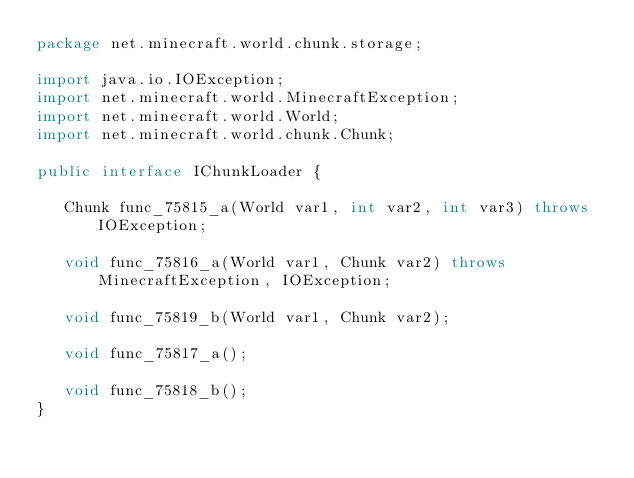<code> <loc_0><loc_0><loc_500><loc_500><_Java_>package net.minecraft.world.chunk.storage;

import java.io.IOException;
import net.minecraft.world.MinecraftException;
import net.minecraft.world.World;
import net.minecraft.world.chunk.Chunk;

public interface IChunkLoader {

   Chunk func_75815_a(World var1, int var2, int var3) throws IOException;

   void func_75816_a(World var1, Chunk var2) throws MinecraftException, IOException;

   void func_75819_b(World var1, Chunk var2);

   void func_75817_a();

   void func_75818_b();
}
</code> 